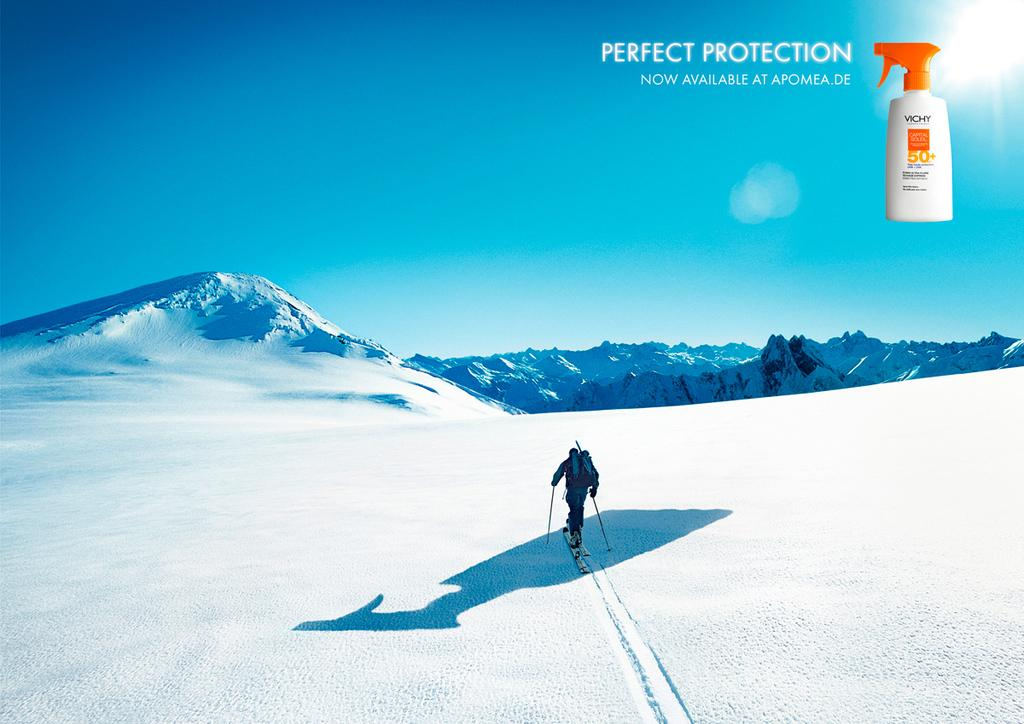<image>
Offer a succinct explanation of the picture presented. a person with skis on and a squirt bottle with perfect protection on it 